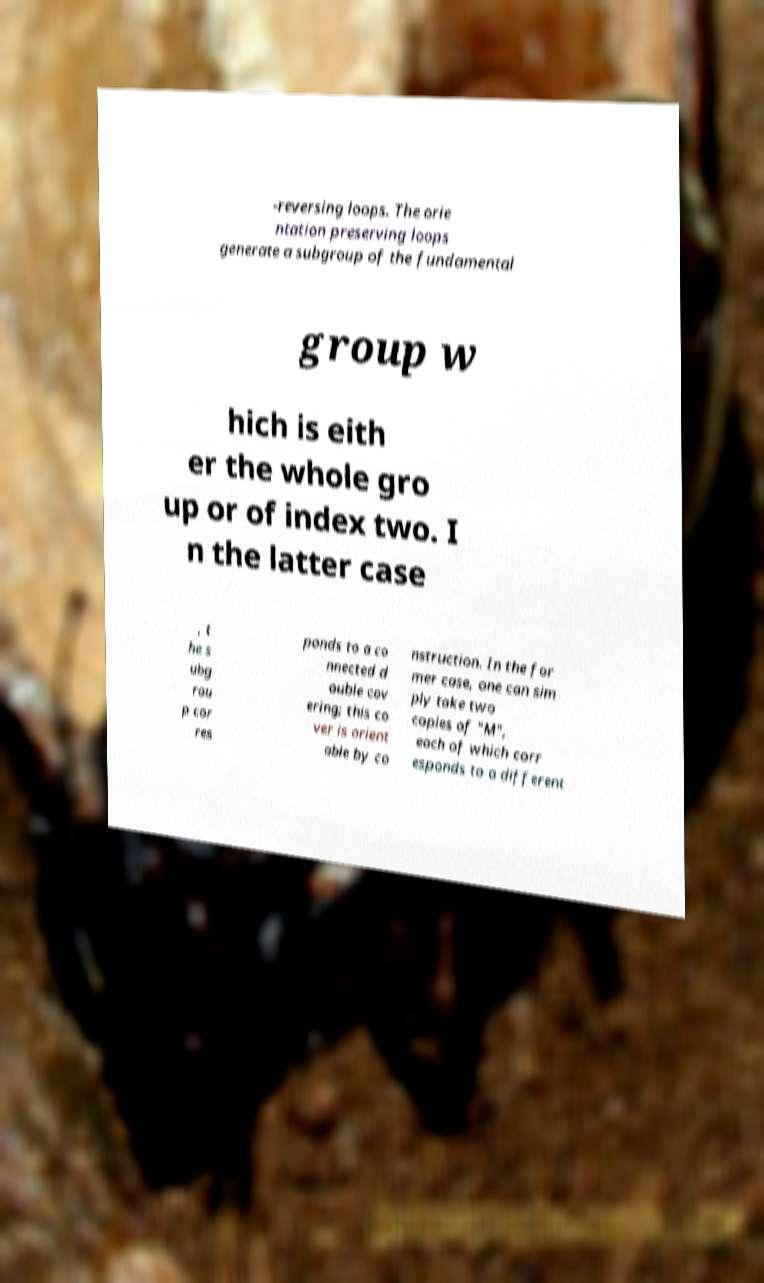I need the written content from this picture converted into text. Can you do that? -reversing loops. The orie ntation preserving loops generate a subgroup of the fundamental group w hich is eith er the whole gro up or of index two. I n the latter case , t he s ubg rou p cor res ponds to a co nnected d ouble cov ering; this co ver is orient able by co nstruction. In the for mer case, one can sim ply take two copies of "M", each of which corr esponds to a different 